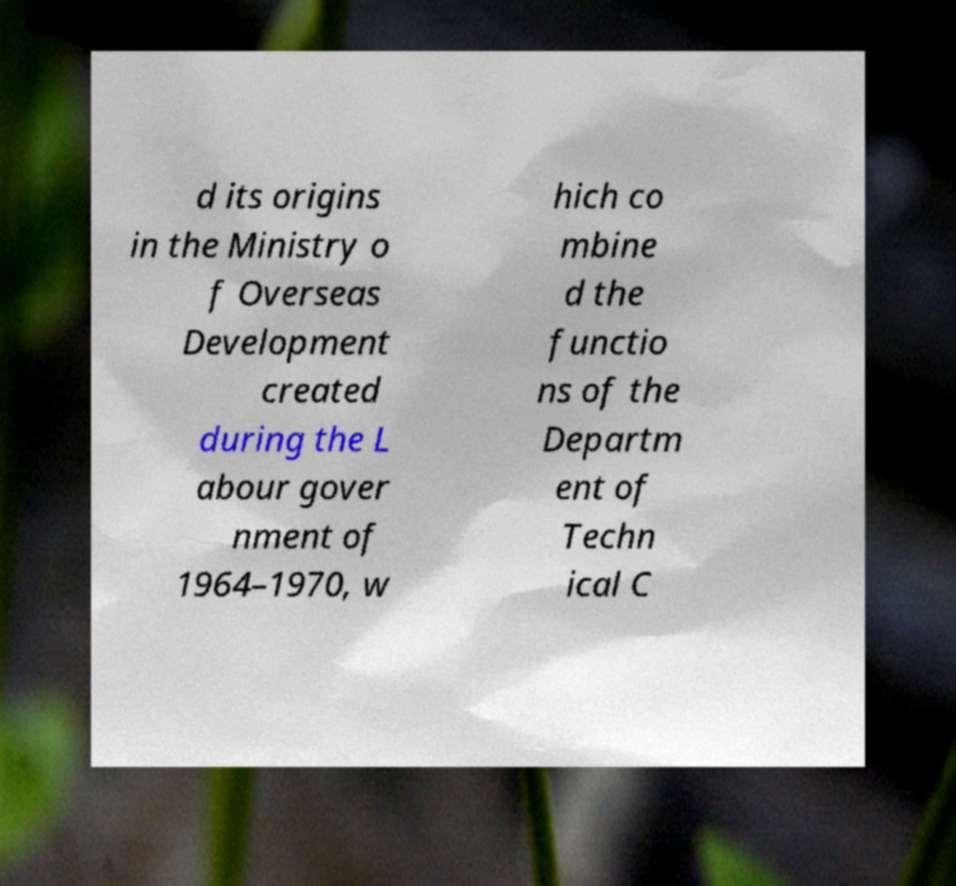Please read and relay the text visible in this image. What does it say? d its origins in the Ministry o f Overseas Development created during the L abour gover nment of 1964–1970, w hich co mbine d the functio ns of the Departm ent of Techn ical C 